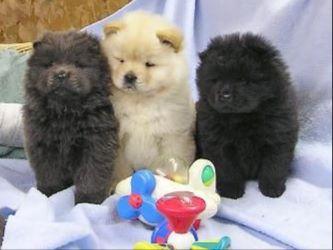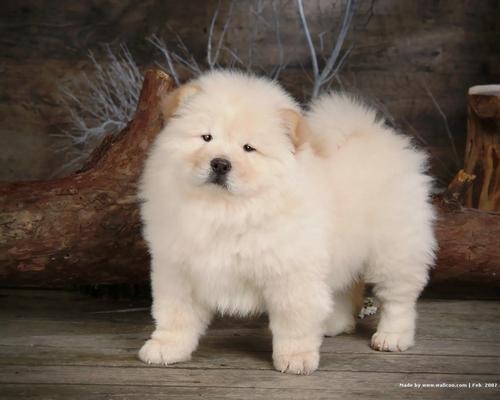The first image is the image on the left, the second image is the image on the right. For the images displayed, is the sentence "In one image, a small white dog is beside driftwood and in front of a wooden wall." factually correct? Answer yes or no. Yes. The first image is the image on the left, the second image is the image on the right. Analyze the images presented: Is the assertion "An image shows three chow pups on a plush surface." valid? Answer yes or no. Yes. 